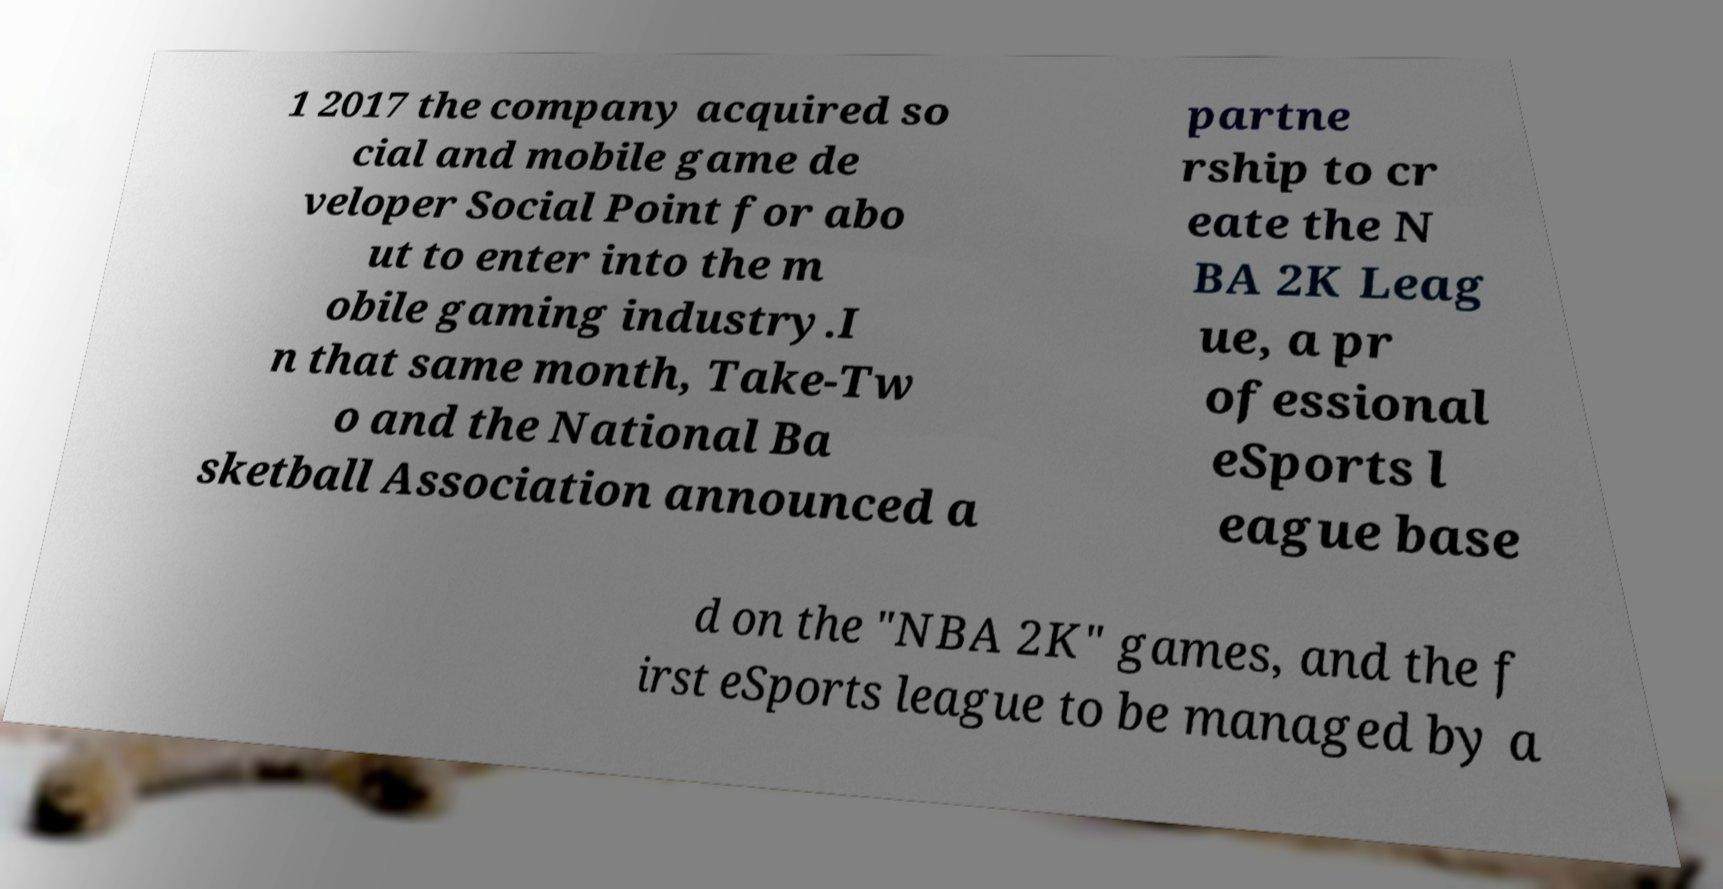Can you read and provide the text displayed in the image?This photo seems to have some interesting text. Can you extract and type it out for me? 1 2017 the company acquired so cial and mobile game de veloper Social Point for abo ut to enter into the m obile gaming industry.I n that same month, Take-Tw o and the National Ba sketball Association announced a partne rship to cr eate the N BA 2K Leag ue, a pr ofessional eSports l eague base d on the "NBA 2K" games, and the f irst eSports league to be managed by a 